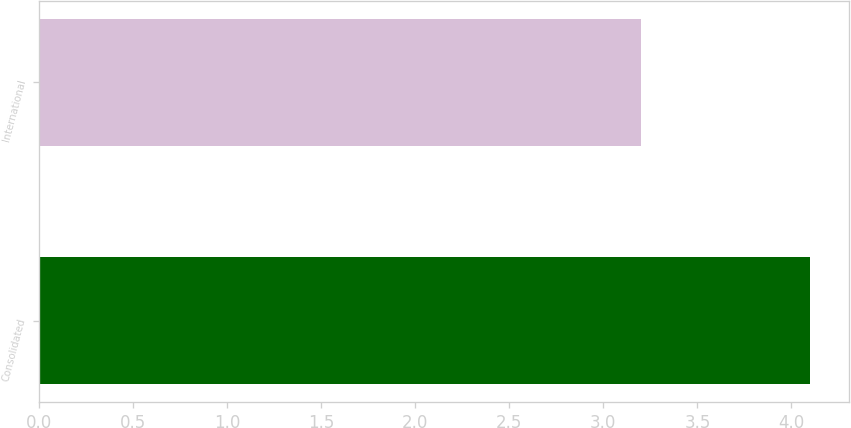Convert chart. <chart><loc_0><loc_0><loc_500><loc_500><bar_chart><fcel>Consolidated<fcel>International<nl><fcel>4.1<fcel>3.2<nl></chart> 